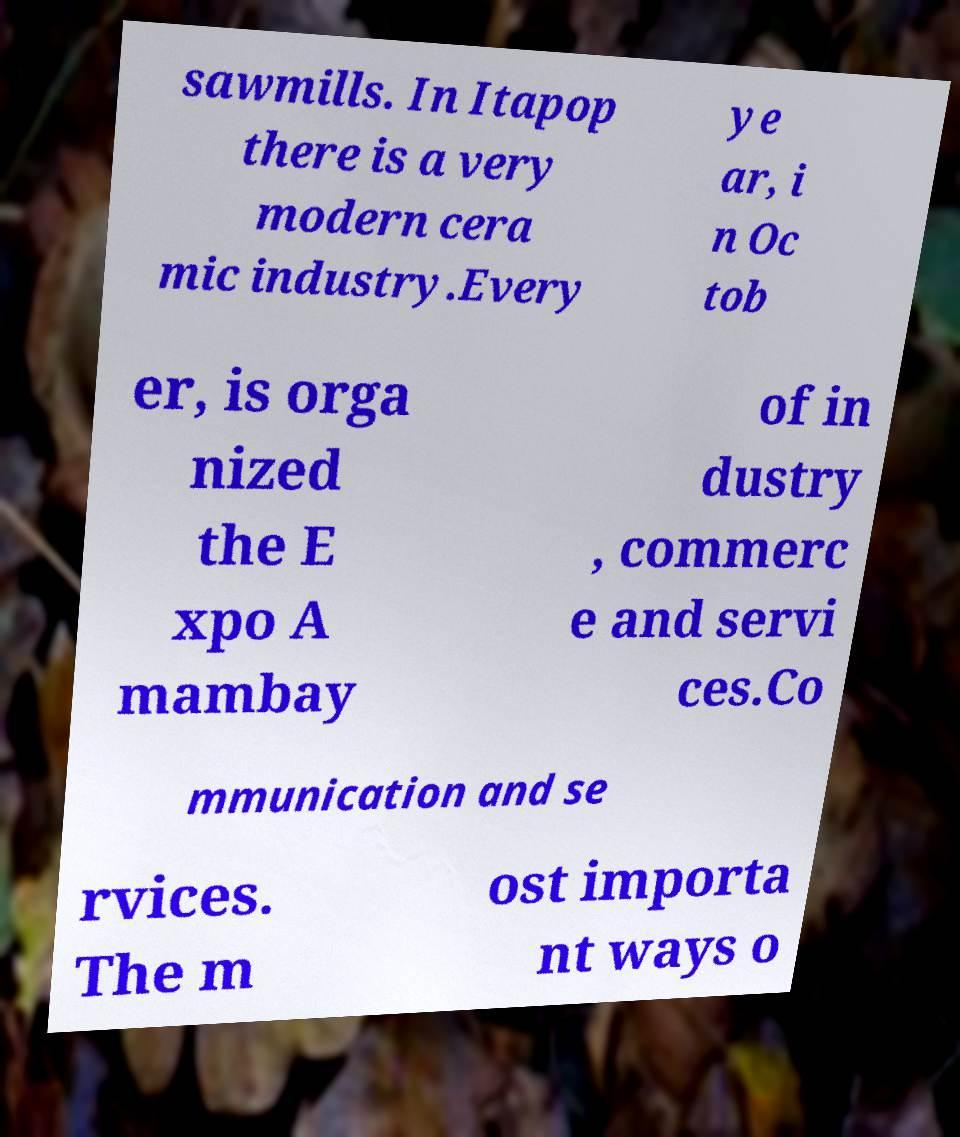Please identify and transcribe the text found in this image. sawmills. In Itapop there is a very modern cera mic industry.Every ye ar, i n Oc tob er, is orga nized the E xpo A mambay of in dustry , commerc e and servi ces.Co mmunication and se rvices. The m ost importa nt ways o 